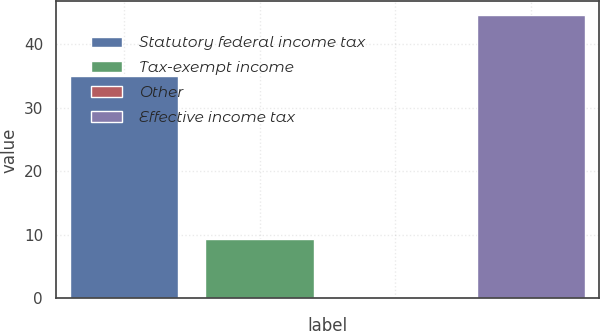Convert chart to OTSL. <chart><loc_0><loc_0><loc_500><loc_500><bar_chart><fcel>Statutory federal income tax<fcel>Tax-exempt income<fcel>Other<fcel>Effective income tax<nl><fcel>35<fcel>9.4<fcel>0.1<fcel>44.5<nl></chart> 